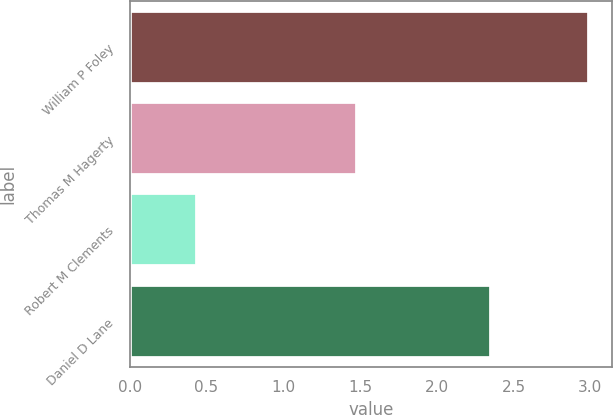Convert chart. <chart><loc_0><loc_0><loc_500><loc_500><bar_chart><fcel>William P Foley<fcel>Thomas M Hagerty<fcel>Robert M Clements<fcel>Daniel D Lane<nl><fcel>2.99<fcel>1.48<fcel>0.44<fcel>2.35<nl></chart> 